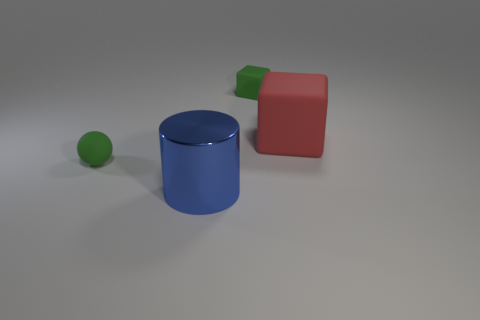There is a rubber thing right of the green thing behind the large red matte block; what color is it?
Your answer should be very brief. Red. Does the green thing behind the small green matte ball have the same shape as the large object that is right of the large metallic cylinder?
Offer a very short reply. Yes. What is the shape of the other red thing that is the same size as the shiny thing?
Your response must be concise. Cube. What color is the other large block that is made of the same material as the green cube?
Keep it short and to the point. Red. There is a red thing; does it have the same shape as the green thing that is to the right of the small rubber ball?
Ensure brevity in your answer.  Yes. There is a blue object that is the same size as the red thing; what is it made of?
Your answer should be compact. Metal. Are there any things that have the same color as the small matte ball?
Ensure brevity in your answer.  Yes. There is a object that is on the right side of the green sphere and in front of the large red block; what shape is it?
Ensure brevity in your answer.  Cylinder. What number of tiny green objects are the same material as the big cube?
Provide a succinct answer. 2. Are there fewer small balls to the right of the sphere than matte objects that are right of the big metal thing?
Keep it short and to the point. Yes. 